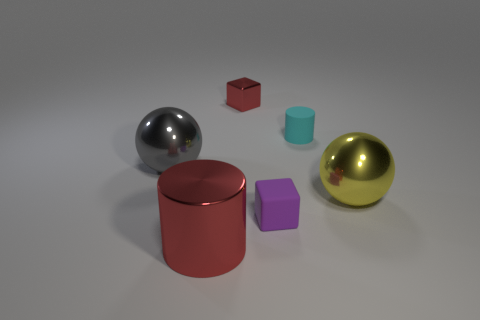Add 4 big gray things. How many objects exist? 10 Subtract all cubes. How many objects are left? 4 Subtract 0 purple cylinders. How many objects are left? 6 Subtract all purple objects. Subtract all cyan rubber cylinders. How many objects are left? 4 Add 3 tiny objects. How many tiny objects are left? 6 Add 2 large brown spheres. How many large brown spheres exist? 2 